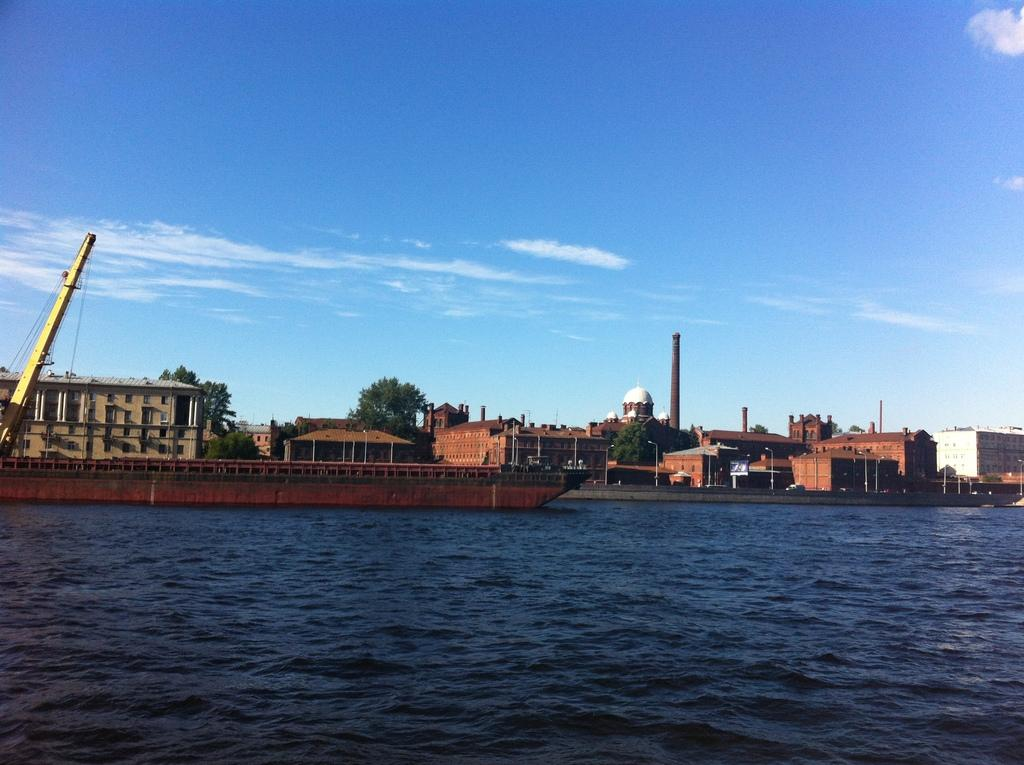What is in the water in the image? There is a boat in the water in the image. What can be seen on the left side of the image? There is a crane on the left side of the image. What is visible in the background of the image? There are houses, poles, and trees in the background. How many degrees can be seen on the giraffe's neck in the image? There is no giraffe present in the image, so it is not possible to determine the number of degrees on its neck. 